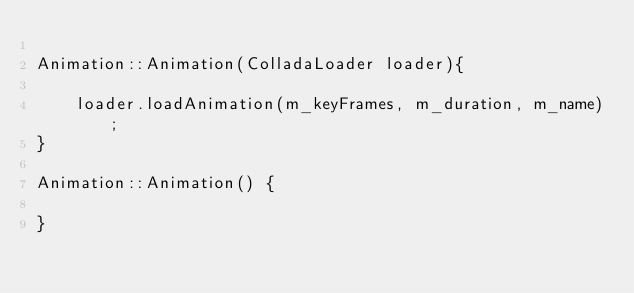<code> <loc_0><loc_0><loc_500><loc_500><_C++_>
Animation::Animation(ColladaLoader loader){
	
	loader.loadAnimation(m_keyFrames, m_duration, m_name);
}

Animation::Animation() {

}</code> 